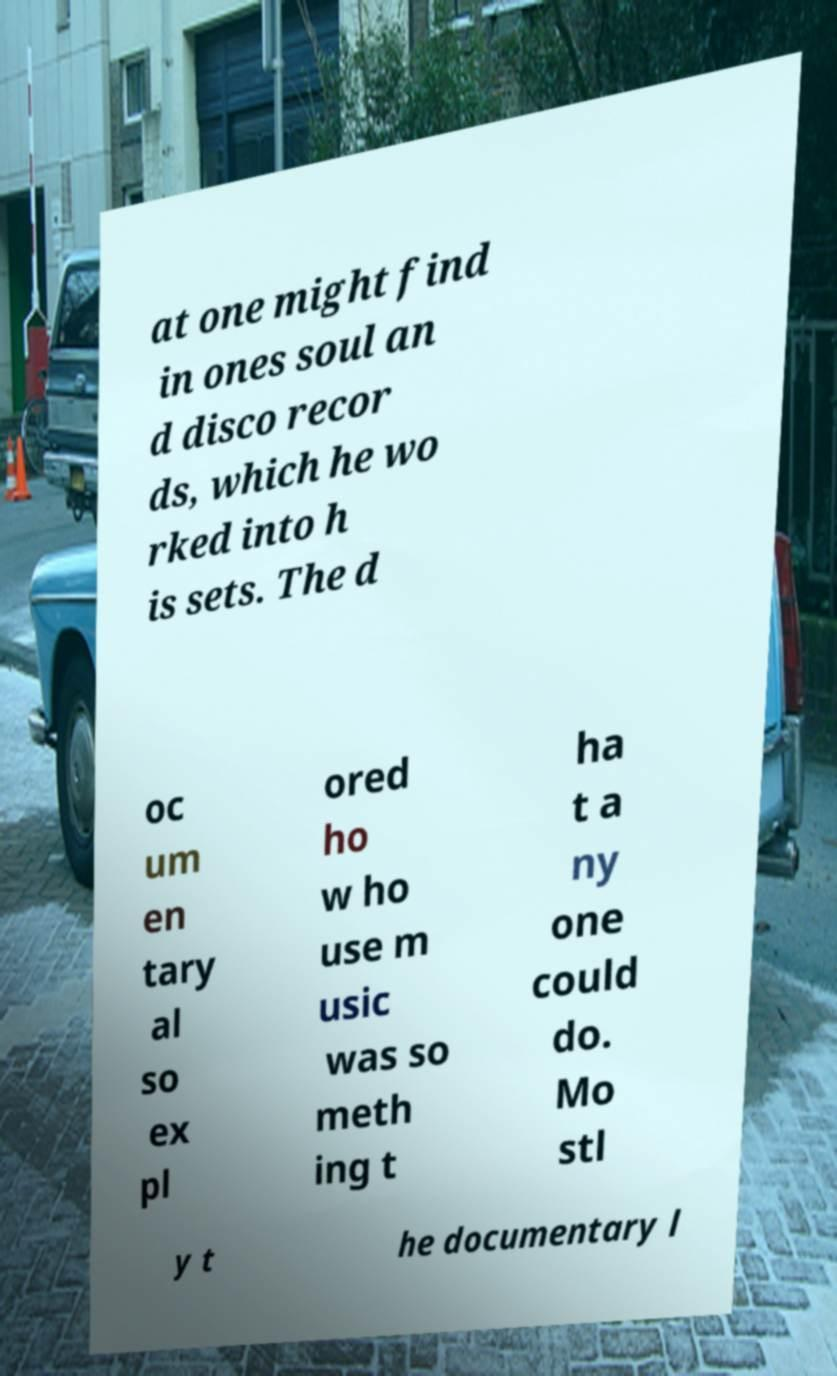What messages or text are displayed in this image? I need them in a readable, typed format. at one might find in ones soul an d disco recor ds, which he wo rked into h is sets. The d oc um en tary al so ex pl ored ho w ho use m usic was so meth ing t ha t a ny one could do. Mo stl y t he documentary l 